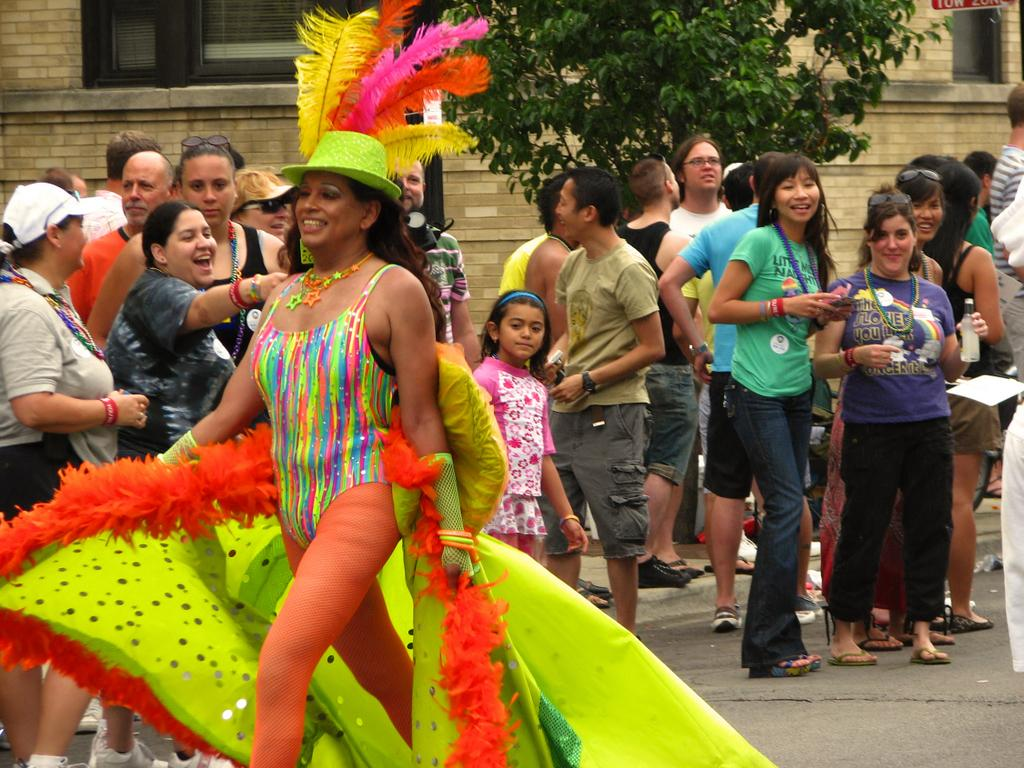How many people are in the image? There is a group of people in the image, but the exact number is not specified. What are the people doing in the image? The people are standing in the image. What can be observed about the clothing of the people? The people are wearing different color dresses. What are some people holding in the image? Some people are holding something, but the specific objects are not mentioned. What type of natural element is present in the image? There is a tree in the image. What type of man-made structure is present in the image? There is a building in the image. What architectural feature can be seen on the building? There are windows visible in the image. What type of fork can be seen in the image? There is no fork present in the image. How does the airport appear in the image? There is no airport present in the image. 